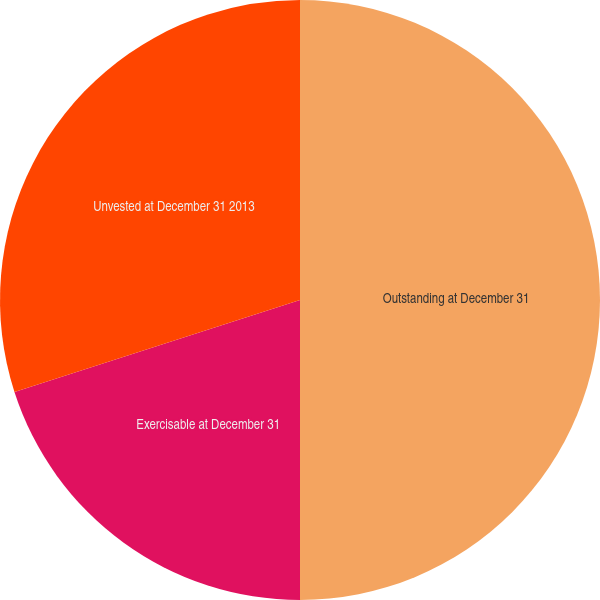Convert chart. <chart><loc_0><loc_0><loc_500><loc_500><pie_chart><fcel>Outstanding at December 31<fcel>Exercisable at December 31<fcel>Unvested at December 31 2013<nl><fcel>50.0%<fcel>20.04%<fcel>29.96%<nl></chart> 